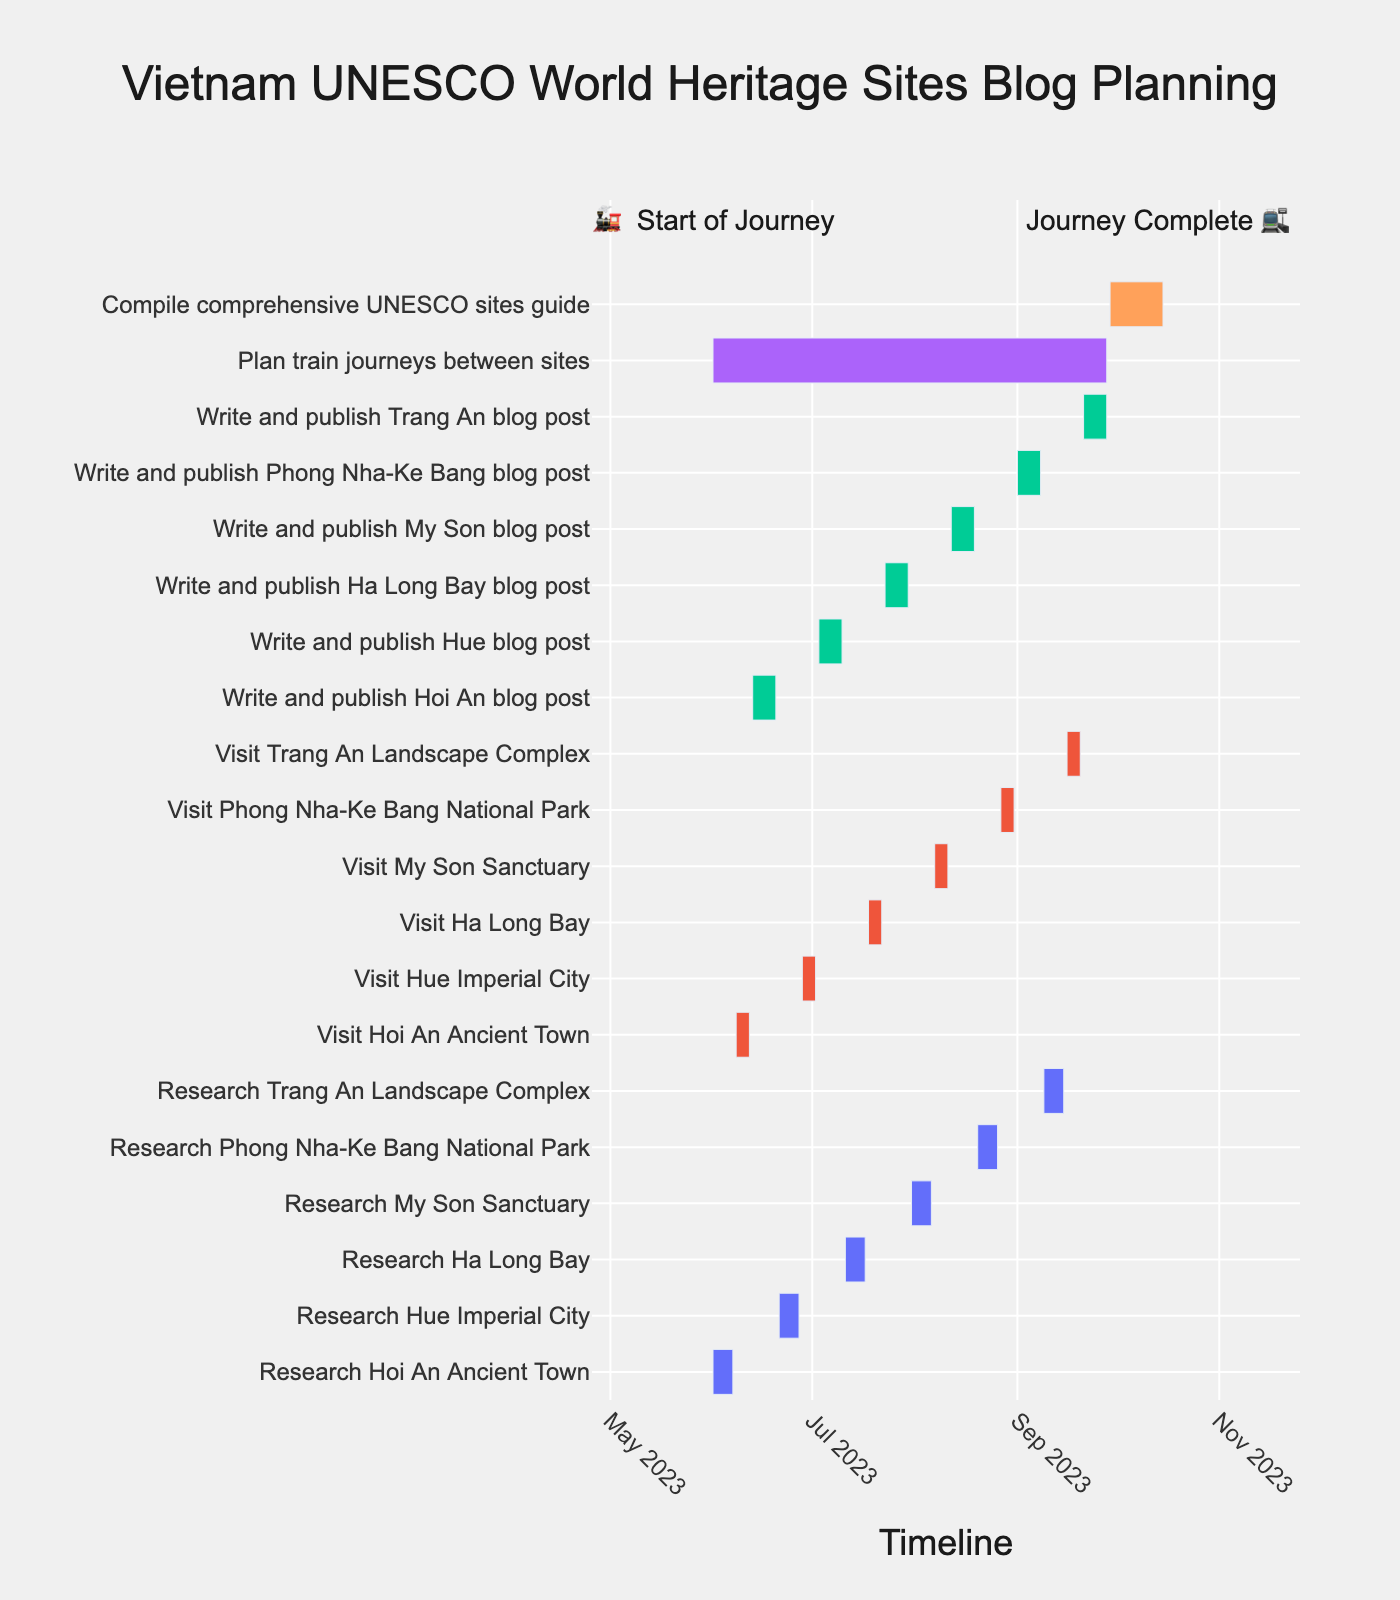What is the time span for the entire planning schedule? The Gantt chart displays the planning schedule from the earliest start date to the latest end date. The earliest start date is June 1, 2023, and the latest end date is October 15, 2023. Therefore, the time span is from June 1, 2023, to October 15, 2023.
Answer: June 1, 2023, to October 15, 2023 How long does each visit to a UNESCO World Heritage Site take? According to the figure, all site visits follow a similar pattern. Each site's visit task spans five days as shown in the Gantt chart. For instance, visits Hoi An Ancient Town (June 8-12), Hue Imperial City (June 28 - July 2), Ha Long Bay (July 18 - 22), My Son Sanctuary (August 7-11), and Phong Nha-Ke Bang National Park (August 27-31).
Answer: 5 days Which task requires the longest duration? To find the longest duration task, we need to compare the lengths of the bars in the Gantt chart. "Compile comprehensive UNESCO sites guide" has the longest bar, spanning from September 29, 2023, to October 15, 2023. This is a total of 17 days.
Answer: Compile comprehensive UNESCO sites guide What tasks are scheduled to occur concurrently on June 1, 2023? By examining the Gantt chart, we can see that both "Research Hoi An Ancient Town" and "Plan train journeys between sites" start on June 1, 2023.
Answer: Research Hoi An Ancient Town and Plan train journeys between sites How many different colors are used to categorize tasks, and what do they represent? The Gantt chart uses different colors to distinguish task types. By inspecting the chart, we can identify five different colors: red for Research, blue for Visit, green for Write, orange for Plan, and purple for Compile.
Answer: 5 colors: Research, Visit, Write, Plan, Compile Which task finishes last before the end of August 2023? To determine which task finishes last in August 2023, we examine tasks ending in that month. The last task in August is "Visit Phong Nha-Ke Bang National Park," ending on August 31, 2023.
Answer: Visit Phong Nha-Ke Bang National Park Does any task overlap with the "Compile comprehensive UNESCO sites guide"? By checking the period from September 29, 2023, to October 15, 2023, we notice that "Plan train journeys between sites" overlaps, ending on September 28, 2023. No other task overlaps within the period of compiling the UNESCO sites guide.
Answer: No Compare the duration of research tasks to visit tasks. Which are generally longer? To answer this, we compare the durations of research tasks and visit tasks in the Gantt chart. Research tasks typically span seven days (e.g., Hoi An: June 1-7), while visit tasks span five days (e.g., Hoi An: June 8-12). Hence, research tasks are generally longer than visit tasks.
Answer: Research tasks What is the duration gap between completing research and starting the visit to Ha Long Bay? The research for Ha Long Bay ends on July 17, 2023. The visit to Ha Long Bay starts on July 18, 2023. The duration gap is from the end date of research to the start date of the visit, which is one day.
Answer: 1 day 